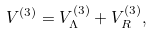Convert formula to latex. <formula><loc_0><loc_0><loc_500><loc_500>V ^ { ( 3 ) } = V _ { \Lambda } ^ { ( 3 ) } + V _ { R } ^ { ( 3 ) } ,</formula> 